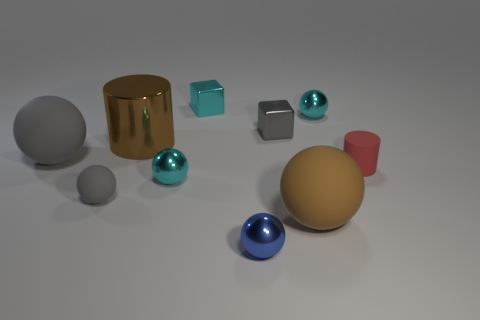Subtract all gray spheres. How many spheres are left? 4 Subtract 4 spheres. How many spheres are left? 2 Subtract all gray spheres. How many spheres are left? 4 Subtract all blue spheres. Subtract all purple cylinders. How many spheres are left? 5 Subtract all spheres. How many objects are left? 4 Subtract all large balls. Subtract all large brown metal cylinders. How many objects are left? 7 Add 3 gray matte balls. How many gray matte balls are left? 5 Add 6 tiny red cylinders. How many tiny red cylinders exist? 7 Subtract 1 blue spheres. How many objects are left? 9 